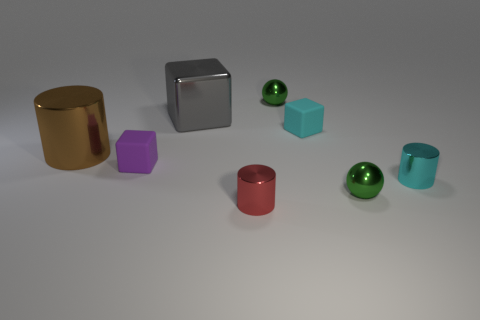Subtract 1 blocks. How many blocks are left? 2 Subtract all matte blocks. How many blocks are left? 1 Add 2 tiny red objects. How many objects exist? 10 Subtract all spheres. How many objects are left? 6 Add 6 cyan shiny cylinders. How many cyan shiny cylinders exist? 7 Subtract 0 cyan balls. How many objects are left? 8 Subtract all large yellow objects. Subtract all cyan shiny cylinders. How many objects are left? 7 Add 5 gray shiny objects. How many gray shiny objects are left? 6 